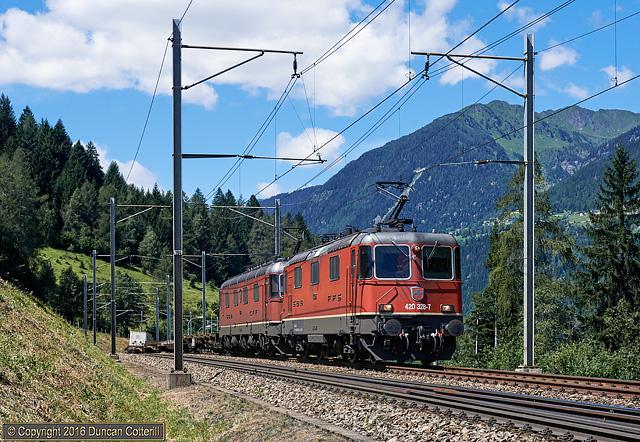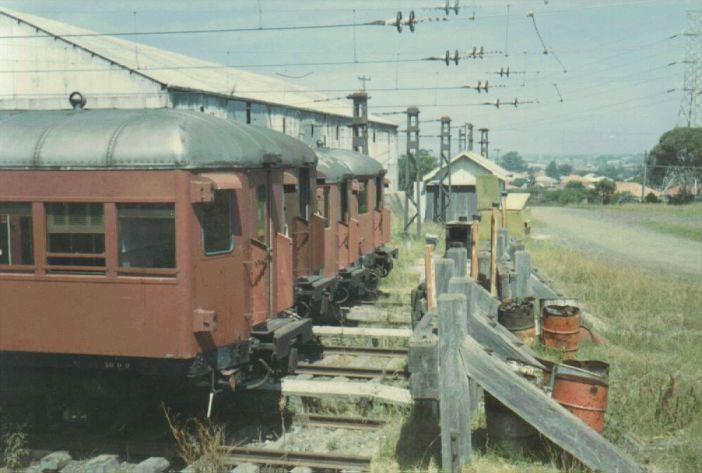The first image is the image on the left, the second image is the image on the right. For the images shown, is this caption "There are two trains in the pair of images, both traveling slightly towards the right." true? Answer yes or no. No. The first image is the image on the left, the second image is the image on the right. For the images displayed, is the sentence "Each image shows one train, which is heading rightward." factually correct? Answer yes or no. No. 